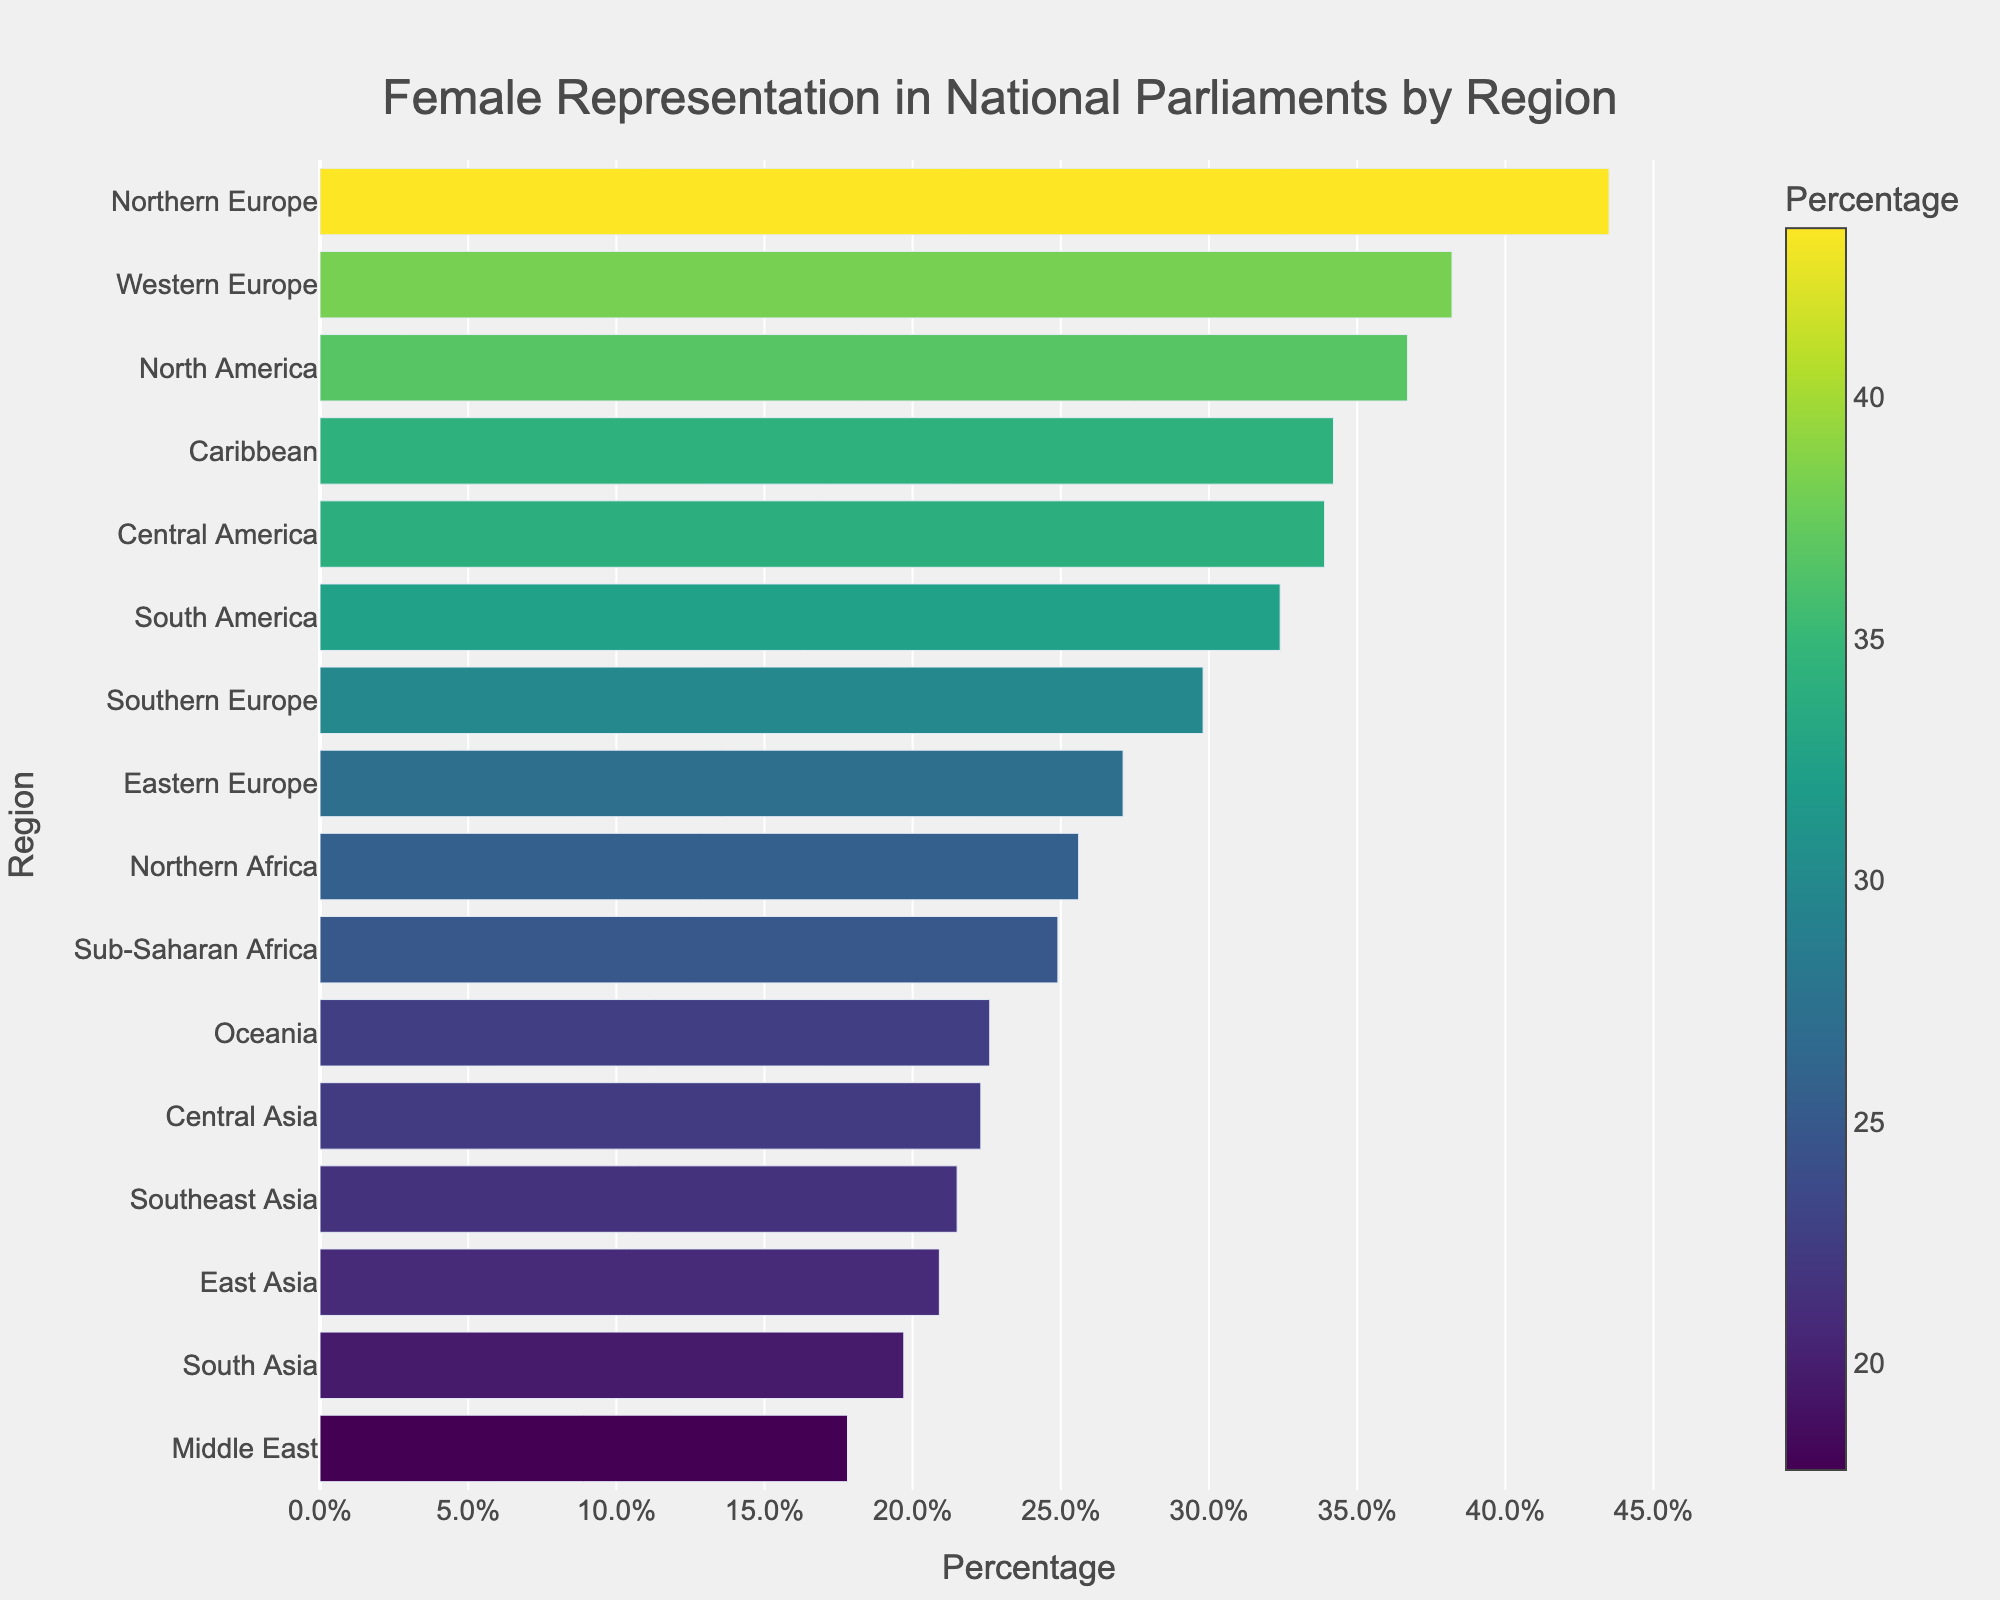Which region has the highest proportion of female representation in national parliaments? The region with the longest bar in the chart and the highest percentage value on the x-axis is Northern Europe at 43.5%.
Answer: Northern Europe Which two regions have the lowest proportions of female representation? The two regions with the shortest bars and lowest percentage values in the chart are the Middle East (17.8%) and South Asia (19.7%).
Answer: Middle East, South Asia What is the percentage difference in female representation between Northern Europe and Sub-Saharan Africa? Northern Europe has 43.5% and Sub-Saharan Africa has 24.9%. The difference is calculated as 43.5% - 24.9% = 18.6%.
Answer: 18.6% Compare the female representation in Western Europe and North America. Which region has higher representation and by how much? Western Europe has 38.2% and North America has 36.7%. Western Europe has a higher representation. The difference is 38.2% - 36.7% = 1.5%.
Answer: Western Europe, 1.5% What is the average percentage of female representation for the regions in Europe (Western, Northern, Southern, Eastern)? The percentages for Western Europe (38.2%), Northern Europe (43.5%), Southern Europe (29.8%), and Eastern Europe (27.1%) are summed and divided by 4. (38.2 + 43.5 + 29.8 + 27.1) / 4 = 34.65%.
Answer: 34.65% Which region's bar is closest in color to North America's bar? The bar closest in color to North America's bar (which represents a percentage of 36.7%) would naturally be the Caribbean, which has a value of 34.2% and similar shades.
Answer: Caribbean If you combine the representation percentages of Northern Africa and Middle East, do they surpass that of Northern Europe? Northern Africa has 25.6% and the Middle East has 17.8%. Their combined percentage is 25.6 + 17.8 = 43.4%, which is just below Northern Europe's 43.5%.
Answer: No What is the median representation percentage for the regions in the data? To find the median, list all the percentages in ascending order. The middle value(s) will be the median. With 16 values, the median is the average of the 8th and 9th values. From the sorted data, the 8th and 9th values are Central America (33.9%) and Caribbean (34.2%). The median is (33.9 + 34.2) / 2 = 34.05%.
Answer: 34.05% How much more female representation does Northern Europe have compared to South America? Northern Europe has 43.5% representation while South America has 32.4%. The difference is 43.5% - 32.4% = 11.1%.
Answer: 11.1% 